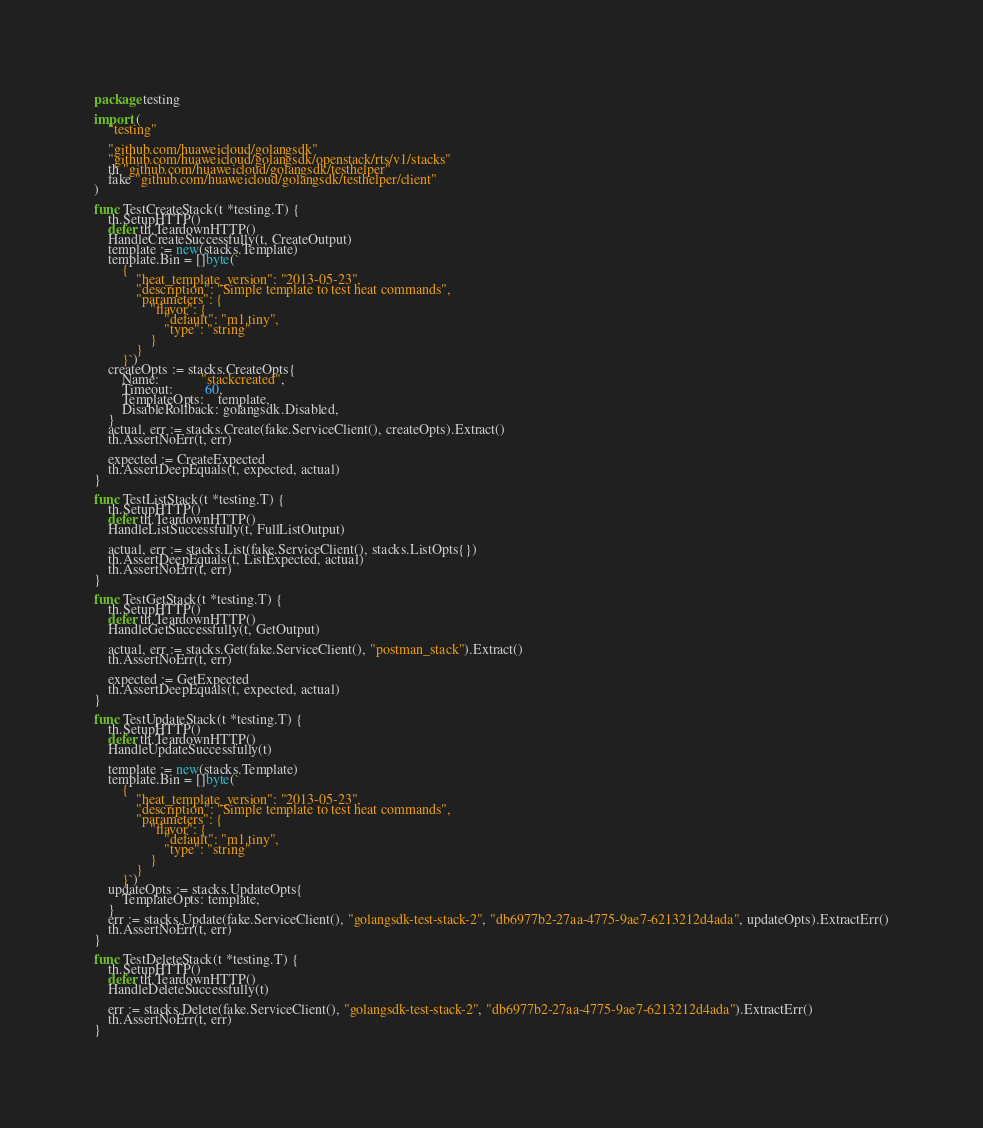<code> <loc_0><loc_0><loc_500><loc_500><_Go_>package testing

import (
	"testing"

	"github.com/huaweicloud/golangsdk"
	"github.com/huaweicloud/golangsdk/openstack/rts/v1/stacks"
	th "github.com/huaweicloud/golangsdk/testhelper"
	fake "github.com/huaweicloud/golangsdk/testhelper/client"
)

func TestCreateStack(t *testing.T) {
	th.SetupHTTP()
	defer th.TeardownHTTP()
	HandleCreateSuccessfully(t, CreateOutput)
	template := new(stacks.Template)
	template.Bin = []byte(`
		{
			"heat_template_version": "2013-05-23",
			"description": "Simple template to test heat commands",
			"parameters": {
				"flavor": {
					"default": "m1.tiny",
					"type": "string"
				}
			}
		}`)
	createOpts := stacks.CreateOpts{
		Name:            "stackcreated",
		Timeout:         60,
		TemplateOpts:    template,
		DisableRollback: golangsdk.Disabled,
	}
	actual, err := stacks.Create(fake.ServiceClient(), createOpts).Extract()
	th.AssertNoErr(t, err)

	expected := CreateExpected
	th.AssertDeepEquals(t, expected, actual)
}

func TestListStack(t *testing.T) {
	th.SetupHTTP()
	defer th.TeardownHTTP()
	HandleListSuccessfully(t, FullListOutput)

	actual, err := stacks.List(fake.ServiceClient(), stacks.ListOpts{})
	th.AssertDeepEquals(t, ListExpected, actual)
	th.AssertNoErr(t, err)
}

func TestGetStack(t *testing.T) {
	th.SetupHTTP()
	defer th.TeardownHTTP()
	HandleGetSuccessfully(t, GetOutput)

	actual, err := stacks.Get(fake.ServiceClient(), "postman_stack").Extract()
	th.AssertNoErr(t, err)

	expected := GetExpected
	th.AssertDeepEquals(t, expected, actual)
}

func TestUpdateStack(t *testing.T) {
	th.SetupHTTP()
	defer th.TeardownHTTP()
	HandleUpdateSuccessfully(t)

	template := new(stacks.Template)
	template.Bin = []byte(`
		{
			"heat_template_version": "2013-05-23",
			"description": "Simple template to test heat commands",
			"parameters": {
				"flavor": {
					"default": "m1.tiny",
					"type": "string"
				}
			}
		}`)
	updateOpts := stacks.UpdateOpts{
		TemplateOpts: template,
	}
	err := stacks.Update(fake.ServiceClient(), "golangsdk-test-stack-2", "db6977b2-27aa-4775-9ae7-6213212d4ada", updateOpts).ExtractErr()
	th.AssertNoErr(t, err)
}

func TestDeleteStack(t *testing.T) {
	th.SetupHTTP()
	defer th.TeardownHTTP()
	HandleDeleteSuccessfully(t)

	err := stacks.Delete(fake.ServiceClient(), "golangsdk-test-stack-2", "db6977b2-27aa-4775-9ae7-6213212d4ada").ExtractErr()
	th.AssertNoErr(t, err)
}
</code> 